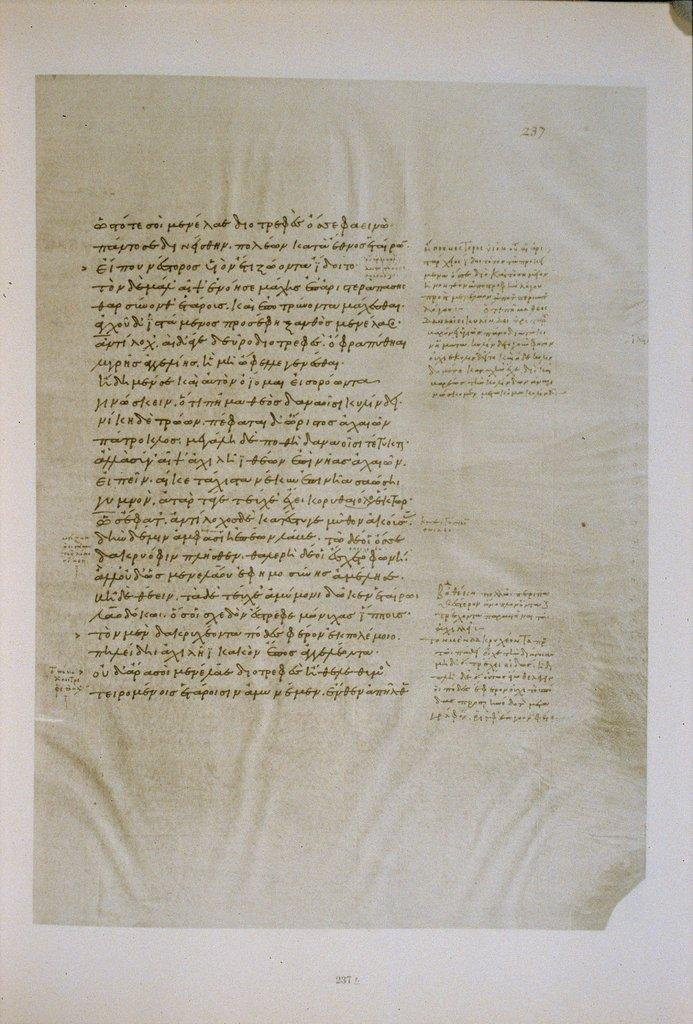<image>
Render a clear and concise summary of the photo. A historical document written in a foreign language. 